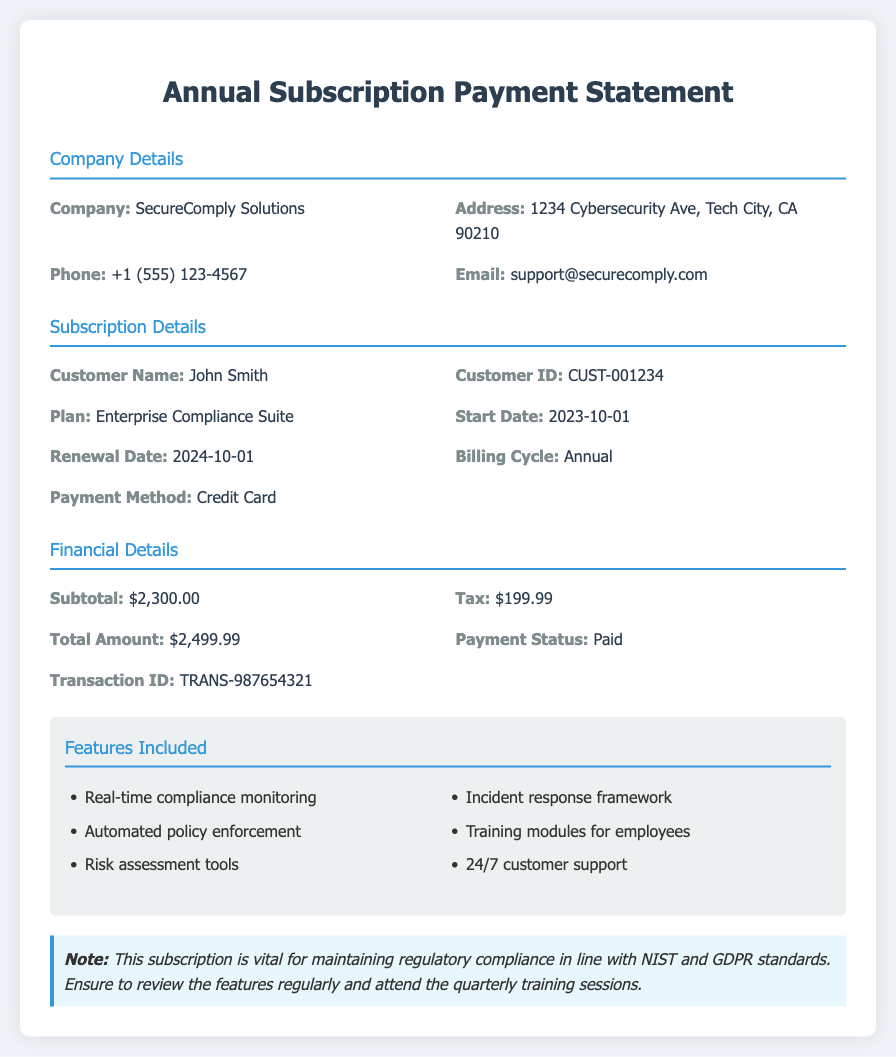What is the customer ID? The customer ID is specified in the document as a unique identifier for the customer, which is CUST-001234.
Answer: CUST-001234 What is the start date of the subscription? The start date is provided in the subscription details section, which shows the subscription began on 2023-10-01.
Answer: 2023-10-01 What is the total amount paid? The total amount is given in the financial details section as the complete amount charged for the subscription, which is $2,499.99.
Answer: $2,499.99 What features are included in the subscription? The features included are listed in a bullet point format in the document, highlighting various tools and services provided under the subscription.
Answer: Real-time compliance monitoring, Automated policy enforcement, Risk assessment tools, Incident response framework, Training modules for employees, 24/7 customer support What is the renewal date? The renewal date is indicated in the subscription details section, showing when the subscription will next be renewed, which is 2024-10-01.
Answer: 2024-10-01 What payment method was used? The payment method refers to how the transaction was completed, which is specified in the subscription details as a Credit Card.
Answer: Credit Card What is the subtotal before tax? The subtotal is listed in the financial details section as the amount before tax is applied, which is $2,300.00.
Answer: $2,300.00 What is the transaction ID? The transaction ID is a unique identifier for the transaction and is provided in the financial details as TRANS-987654321.
Answer: TRANS-987654321 What overall service does the subscription provide? The subscription is described in the plan section as an Enterprise Compliance Suite, which provides various compliance-related features for organizations.
Answer: Enterprise Compliance Suite 